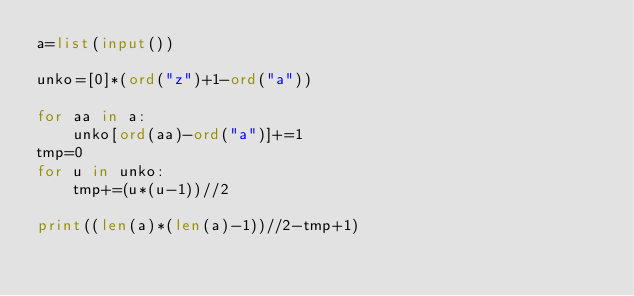Convert code to text. <code><loc_0><loc_0><loc_500><loc_500><_Python_>a=list(input())

unko=[0]*(ord("z")+1-ord("a"))

for aa in a:
    unko[ord(aa)-ord("a")]+=1
tmp=0
for u in unko:
    tmp+=(u*(u-1))//2

print((len(a)*(len(a)-1))//2-tmp+1)</code> 